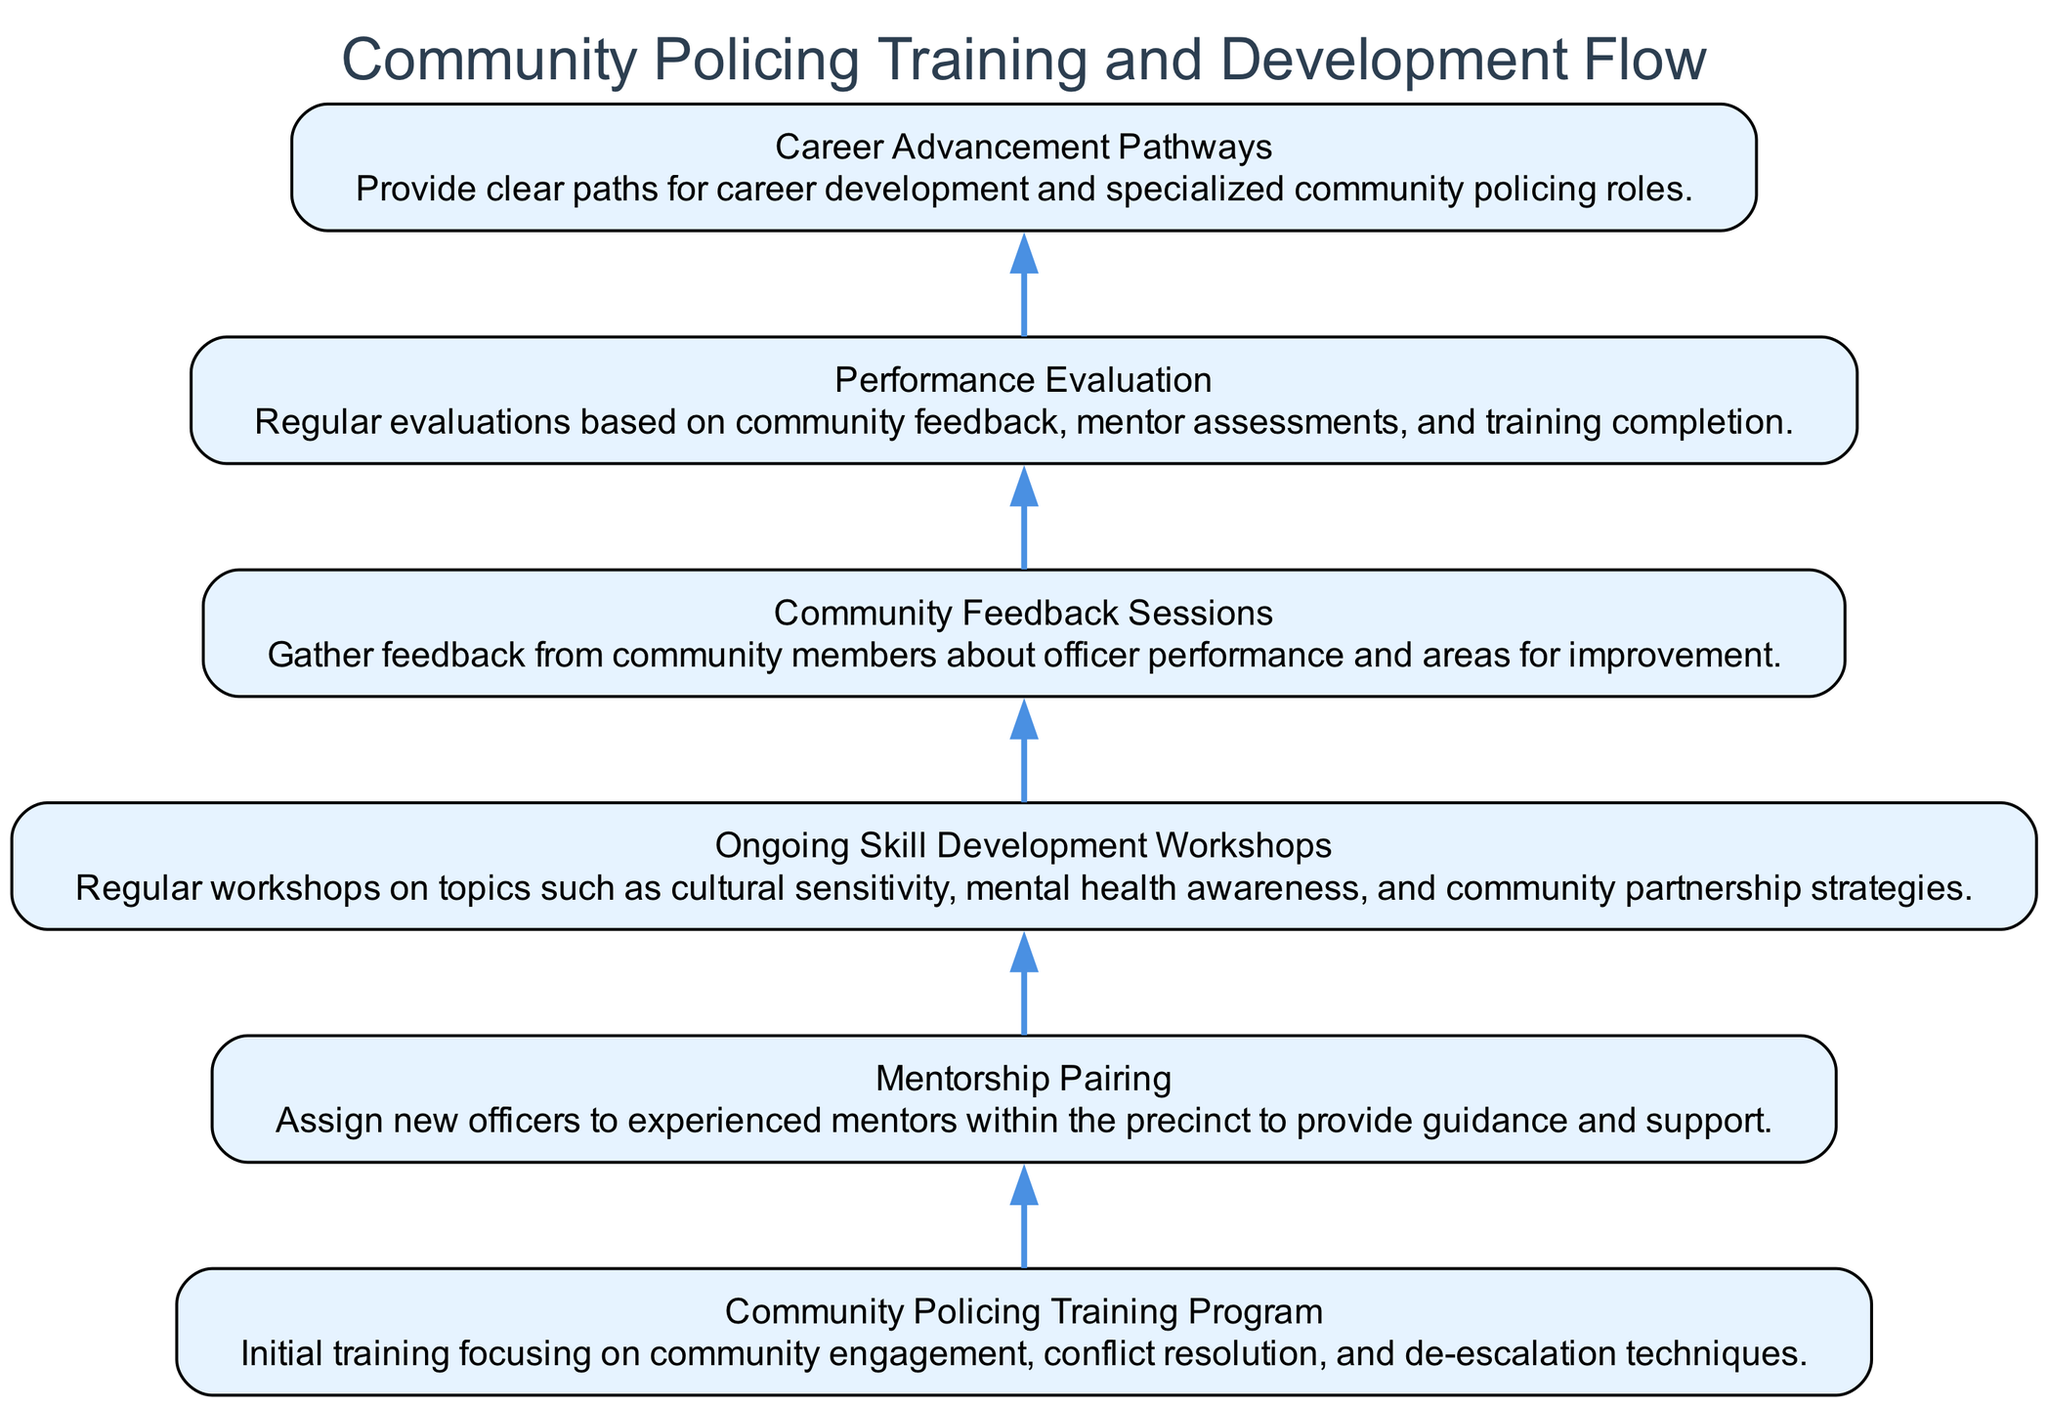What is the first stage in the training flow? The first stage in the diagram is "Community Policing Training Program," which is the starting point of the flow and focuses on initial training for officers.
Answer: Community Policing Training Program How many total stages are depicted in the flow? By counting each distinct node in the diagram, there are six stages outlined, which represent the complete training and development flow for community policing officers.
Answer: 6 What follows "Mentorship Pairing" in the flow? The stage that follows "Mentorship Pairing" is "Ongoing Skill Development Workshops," indicating the progression of development after mentorship.
Answer: Ongoing Skill Development Workshops Which stage involves community input? The stage that involves community input for feedback about officer performance is "Community Feedback Sessions." It indicates a focus on obtaining community perspectives.
Answer: Community Feedback Sessions How are the evaluation processes structured in the flow? The evaluation processes are structured as "Performance Evaluation," which is based on community feedback and mentor assessments, assuring a comprehensive evaluation after other training stages are completed.
Answer: Performance Evaluation What connects "Community Feedback Sessions" to the next stage? "Community Feedback Sessions" is followed by "Performance Evaluation," showing the flow from garnering community insight to assessing officer performance.
Answer: Performance Evaluation What does the last stage signify in terms of career progression? The last stage, "Career Advancement Pathways," signifies the provision of clear career development opportunities for officers specializing in community policing roles.
Answer: Career Advancement Pathways Which two stages focus on skill development? The two stages that focus on skill development are "Ongoing Skill Development Workshops" and "Community Policing Training Program," both emphasizing essential skills in community policing.
Answer: Ongoing Skill Development Workshops and Community Policing Training Program What role does mentorship play in the flow? Mentorship is embodied in the "Mentorship Pairing" stage, where new officers are assigned to experienced mentors, highlighting the importance of guidance and support in the training process.
Answer: Mentorship Pairing 